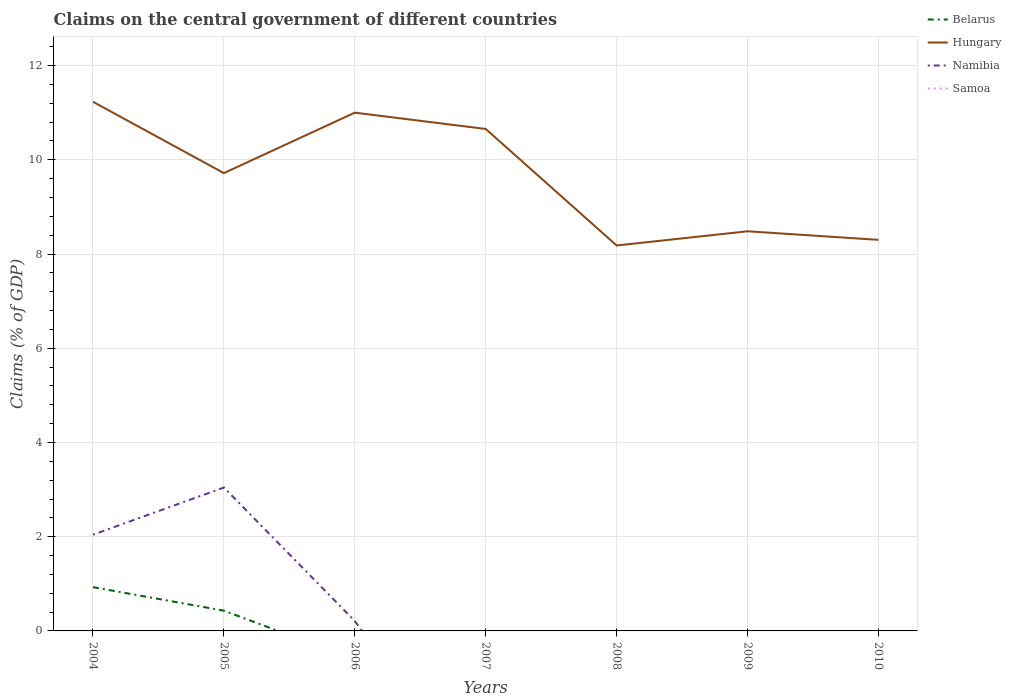Is the number of lines equal to the number of legend labels?
Your answer should be very brief. No. Across all years, what is the maximum percentage of GDP claimed on the central government in Samoa?
Make the answer very short. 0. What is the total percentage of GDP claimed on the central government in Hungary in the graph?
Make the answer very short. 2.17. What is the difference between the highest and the second highest percentage of GDP claimed on the central government in Hungary?
Your answer should be compact. 3.05. Is the percentage of GDP claimed on the central government in Samoa strictly greater than the percentage of GDP claimed on the central government in Hungary over the years?
Ensure brevity in your answer.  Yes. How many years are there in the graph?
Make the answer very short. 7. Are the values on the major ticks of Y-axis written in scientific E-notation?
Ensure brevity in your answer.  No. Does the graph contain any zero values?
Your answer should be compact. Yes. What is the title of the graph?
Offer a terse response. Claims on the central government of different countries. What is the label or title of the X-axis?
Provide a short and direct response. Years. What is the label or title of the Y-axis?
Provide a short and direct response. Claims (% of GDP). What is the Claims (% of GDP) of Belarus in 2004?
Ensure brevity in your answer.  0.93. What is the Claims (% of GDP) of Hungary in 2004?
Your answer should be very brief. 11.23. What is the Claims (% of GDP) of Namibia in 2004?
Give a very brief answer. 2.04. What is the Claims (% of GDP) of Belarus in 2005?
Provide a short and direct response. 0.43. What is the Claims (% of GDP) of Hungary in 2005?
Offer a terse response. 9.72. What is the Claims (% of GDP) in Namibia in 2005?
Give a very brief answer. 3.04. What is the Claims (% of GDP) in Belarus in 2006?
Your answer should be very brief. 0. What is the Claims (% of GDP) of Hungary in 2006?
Provide a succinct answer. 11. What is the Claims (% of GDP) of Namibia in 2006?
Offer a terse response. 0.21. What is the Claims (% of GDP) of Hungary in 2007?
Your response must be concise. 10.66. What is the Claims (% of GDP) of Namibia in 2007?
Provide a succinct answer. 0. What is the Claims (% of GDP) of Samoa in 2007?
Offer a terse response. 0. What is the Claims (% of GDP) of Hungary in 2008?
Give a very brief answer. 8.18. What is the Claims (% of GDP) of Belarus in 2009?
Your answer should be very brief. 0. What is the Claims (% of GDP) of Hungary in 2009?
Make the answer very short. 8.48. What is the Claims (% of GDP) of Namibia in 2009?
Ensure brevity in your answer.  0. What is the Claims (% of GDP) in Samoa in 2009?
Ensure brevity in your answer.  0. What is the Claims (% of GDP) in Belarus in 2010?
Offer a terse response. 0. What is the Claims (% of GDP) of Hungary in 2010?
Give a very brief answer. 8.3. What is the Claims (% of GDP) of Namibia in 2010?
Your response must be concise. 0. What is the Claims (% of GDP) of Samoa in 2010?
Provide a succinct answer. 0. Across all years, what is the maximum Claims (% of GDP) in Belarus?
Your response must be concise. 0.93. Across all years, what is the maximum Claims (% of GDP) of Hungary?
Your answer should be compact. 11.23. Across all years, what is the maximum Claims (% of GDP) in Namibia?
Your answer should be very brief. 3.04. Across all years, what is the minimum Claims (% of GDP) of Belarus?
Provide a short and direct response. 0. Across all years, what is the minimum Claims (% of GDP) in Hungary?
Ensure brevity in your answer.  8.18. Across all years, what is the minimum Claims (% of GDP) of Namibia?
Your response must be concise. 0. What is the total Claims (% of GDP) of Belarus in the graph?
Keep it short and to the point. 1.36. What is the total Claims (% of GDP) in Hungary in the graph?
Your answer should be compact. 67.57. What is the total Claims (% of GDP) in Namibia in the graph?
Keep it short and to the point. 5.3. What is the total Claims (% of GDP) in Samoa in the graph?
Your response must be concise. 0. What is the difference between the Claims (% of GDP) in Belarus in 2004 and that in 2005?
Provide a short and direct response. 0.5. What is the difference between the Claims (% of GDP) in Hungary in 2004 and that in 2005?
Keep it short and to the point. 1.51. What is the difference between the Claims (% of GDP) in Namibia in 2004 and that in 2005?
Ensure brevity in your answer.  -1. What is the difference between the Claims (% of GDP) of Hungary in 2004 and that in 2006?
Offer a very short reply. 0.23. What is the difference between the Claims (% of GDP) in Namibia in 2004 and that in 2006?
Offer a terse response. 1.83. What is the difference between the Claims (% of GDP) in Hungary in 2004 and that in 2007?
Provide a succinct answer. 0.58. What is the difference between the Claims (% of GDP) of Hungary in 2004 and that in 2008?
Provide a short and direct response. 3.05. What is the difference between the Claims (% of GDP) in Hungary in 2004 and that in 2009?
Give a very brief answer. 2.75. What is the difference between the Claims (% of GDP) in Hungary in 2004 and that in 2010?
Offer a very short reply. 2.93. What is the difference between the Claims (% of GDP) in Hungary in 2005 and that in 2006?
Ensure brevity in your answer.  -1.28. What is the difference between the Claims (% of GDP) of Namibia in 2005 and that in 2006?
Make the answer very short. 2.83. What is the difference between the Claims (% of GDP) of Hungary in 2005 and that in 2007?
Your response must be concise. -0.94. What is the difference between the Claims (% of GDP) in Hungary in 2005 and that in 2008?
Keep it short and to the point. 1.54. What is the difference between the Claims (% of GDP) of Hungary in 2005 and that in 2009?
Keep it short and to the point. 1.24. What is the difference between the Claims (% of GDP) in Hungary in 2005 and that in 2010?
Ensure brevity in your answer.  1.42. What is the difference between the Claims (% of GDP) of Hungary in 2006 and that in 2007?
Provide a succinct answer. 0.35. What is the difference between the Claims (% of GDP) in Hungary in 2006 and that in 2008?
Provide a short and direct response. 2.82. What is the difference between the Claims (% of GDP) in Hungary in 2006 and that in 2009?
Your answer should be very brief. 2.52. What is the difference between the Claims (% of GDP) of Hungary in 2006 and that in 2010?
Your response must be concise. 2.7. What is the difference between the Claims (% of GDP) of Hungary in 2007 and that in 2008?
Make the answer very short. 2.47. What is the difference between the Claims (% of GDP) in Hungary in 2007 and that in 2009?
Your answer should be very brief. 2.17. What is the difference between the Claims (% of GDP) of Hungary in 2007 and that in 2010?
Your answer should be compact. 2.35. What is the difference between the Claims (% of GDP) in Hungary in 2008 and that in 2009?
Your answer should be compact. -0.3. What is the difference between the Claims (% of GDP) of Hungary in 2008 and that in 2010?
Offer a very short reply. -0.12. What is the difference between the Claims (% of GDP) in Hungary in 2009 and that in 2010?
Give a very brief answer. 0.18. What is the difference between the Claims (% of GDP) of Belarus in 2004 and the Claims (% of GDP) of Hungary in 2005?
Make the answer very short. -8.79. What is the difference between the Claims (% of GDP) of Belarus in 2004 and the Claims (% of GDP) of Namibia in 2005?
Make the answer very short. -2.12. What is the difference between the Claims (% of GDP) in Hungary in 2004 and the Claims (% of GDP) in Namibia in 2005?
Provide a succinct answer. 8.19. What is the difference between the Claims (% of GDP) in Belarus in 2004 and the Claims (% of GDP) in Hungary in 2006?
Ensure brevity in your answer.  -10.07. What is the difference between the Claims (% of GDP) in Belarus in 2004 and the Claims (% of GDP) in Namibia in 2006?
Your answer should be very brief. 0.72. What is the difference between the Claims (% of GDP) of Hungary in 2004 and the Claims (% of GDP) of Namibia in 2006?
Provide a succinct answer. 11.02. What is the difference between the Claims (% of GDP) of Belarus in 2004 and the Claims (% of GDP) of Hungary in 2007?
Offer a very short reply. -9.73. What is the difference between the Claims (% of GDP) in Belarus in 2004 and the Claims (% of GDP) in Hungary in 2008?
Offer a very short reply. -7.25. What is the difference between the Claims (% of GDP) in Belarus in 2004 and the Claims (% of GDP) in Hungary in 2009?
Offer a very short reply. -7.55. What is the difference between the Claims (% of GDP) of Belarus in 2004 and the Claims (% of GDP) of Hungary in 2010?
Keep it short and to the point. -7.37. What is the difference between the Claims (% of GDP) in Belarus in 2005 and the Claims (% of GDP) in Hungary in 2006?
Your response must be concise. -10.57. What is the difference between the Claims (% of GDP) in Belarus in 2005 and the Claims (% of GDP) in Namibia in 2006?
Keep it short and to the point. 0.22. What is the difference between the Claims (% of GDP) in Hungary in 2005 and the Claims (% of GDP) in Namibia in 2006?
Give a very brief answer. 9.51. What is the difference between the Claims (% of GDP) in Belarus in 2005 and the Claims (% of GDP) in Hungary in 2007?
Provide a succinct answer. -10.23. What is the difference between the Claims (% of GDP) of Belarus in 2005 and the Claims (% of GDP) of Hungary in 2008?
Your answer should be very brief. -7.75. What is the difference between the Claims (% of GDP) of Belarus in 2005 and the Claims (% of GDP) of Hungary in 2009?
Keep it short and to the point. -8.05. What is the difference between the Claims (% of GDP) of Belarus in 2005 and the Claims (% of GDP) of Hungary in 2010?
Your response must be concise. -7.87. What is the average Claims (% of GDP) of Belarus per year?
Give a very brief answer. 0.19. What is the average Claims (% of GDP) of Hungary per year?
Give a very brief answer. 9.65. What is the average Claims (% of GDP) of Namibia per year?
Give a very brief answer. 0.76. What is the average Claims (% of GDP) of Samoa per year?
Your answer should be very brief. 0. In the year 2004, what is the difference between the Claims (% of GDP) of Belarus and Claims (% of GDP) of Hungary?
Offer a terse response. -10.3. In the year 2004, what is the difference between the Claims (% of GDP) of Belarus and Claims (% of GDP) of Namibia?
Ensure brevity in your answer.  -1.11. In the year 2004, what is the difference between the Claims (% of GDP) of Hungary and Claims (% of GDP) of Namibia?
Your answer should be very brief. 9.19. In the year 2005, what is the difference between the Claims (% of GDP) of Belarus and Claims (% of GDP) of Hungary?
Offer a terse response. -9.29. In the year 2005, what is the difference between the Claims (% of GDP) of Belarus and Claims (% of GDP) of Namibia?
Keep it short and to the point. -2.61. In the year 2005, what is the difference between the Claims (% of GDP) in Hungary and Claims (% of GDP) in Namibia?
Make the answer very short. 6.67. In the year 2006, what is the difference between the Claims (% of GDP) in Hungary and Claims (% of GDP) in Namibia?
Keep it short and to the point. 10.79. What is the ratio of the Claims (% of GDP) of Belarus in 2004 to that in 2005?
Make the answer very short. 2.16. What is the ratio of the Claims (% of GDP) of Hungary in 2004 to that in 2005?
Offer a very short reply. 1.16. What is the ratio of the Claims (% of GDP) of Namibia in 2004 to that in 2005?
Keep it short and to the point. 0.67. What is the ratio of the Claims (% of GDP) in Hungary in 2004 to that in 2006?
Your answer should be very brief. 1.02. What is the ratio of the Claims (% of GDP) of Namibia in 2004 to that in 2006?
Your response must be concise. 9.74. What is the ratio of the Claims (% of GDP) of Hungary in 2004 to that in 2007?
Your answer should be compact. 1.05. What is the ratio of the Claims (% of GDP) of Hungary in 2004 to that in 2008?
Keep it short and to the point. 1.37. What is the ratio of the Claims (% of GDP) in Hungary in 2004 to that in 2009?
Provide a short and direct response. 1.32. What is the ratio of the Claims (% of GDP) of Hungary in 2004 to that in 2010?
Offer a terse response. 1.35. What is the ratio of the Claims (% of GDP) of Hungary in 2005 to that in 2006?
Provide a succinct answer. 0.88. What is the ratio of the Claims (% of GDP) in Namibia in 2005 to that in 2006?
Ensure brevity in your answer.  14.51. What is the ratio of the Claims (% of GDP) of Hungary in 2005 to that in 2007?
Offer a terse response. 0.91. What is the ratio of the Claims (% of GDP) of Hungary in 2005 to that in 2008?
Your answer should be very brief. 1.19. What is the ratio of the Claims (% of GDP) in Hungary in 2005 to that in 2009?
Provide a succinct answer. 1.15. What is the ratio of the Claims (% of GDP) of Hungary in 2005 to that in 2010?
Make the answer very short. 1.17. What is the ratio of the Claims (% of GDP) in Hungary in 2006 to that in 2007?
Offer a terse response. 1.03. What is the ratio of the Claims (% of GDP) of Hungary in 2006 to that in 2008?
Make the answer very short. 1.34. What is the ratio of the Claims (% of GDP) of Hungary in 2006 to that in 2009?
Give a very brief answer. 1.3. What is the ratio of the Claims (% of GDP) in Hungary in 2006 to that in 2010?
Provide a short and direct response. 1.33. What is the ratio of the Claims (% of GDP) of Hungary in 2007 to that in 2008?
Keep it short and to the point. 1.3. What is the ratio of the Claims (% of GDP) in Hungary in 2007 to that in 2009?
Ensure brevity in your answer.  1.26. What is the ratio of the Claims (% of GDP) in Hungary in 2007 to that in 2010?
Offer a terse response. 1.28. What is the ratio of the Claims (% of GDP) in Hungary in 2008 to that in 2009?
Your answer should be very brief. 0.96. What is the ratio of the Claims (% of GDP) in Hungary in 2008 to that in 2010?
Make the answer very short. 0.99. What is the ratio of the Claims (% of GDP) in Hungary in 2009 to that in 2010?
Provide a succinct answer. 1.02. What is the difference between the highest and the second highest Claims (% of GDP) of Hungary?
Provide a succinct answer. 0.23. What is the difference between the highest and the lowest Claims (% of GDP) in Belarus?
Keep it short and to the point. 0.93. What is the difference between the highest and the lowest Claims (% of GDP) in Hungary?
Your response must be concise. 3.05. What is the difference between the highest and the lowest Claims (% of GDP) in Namibia?
Your answer should be compact. 3.04. 